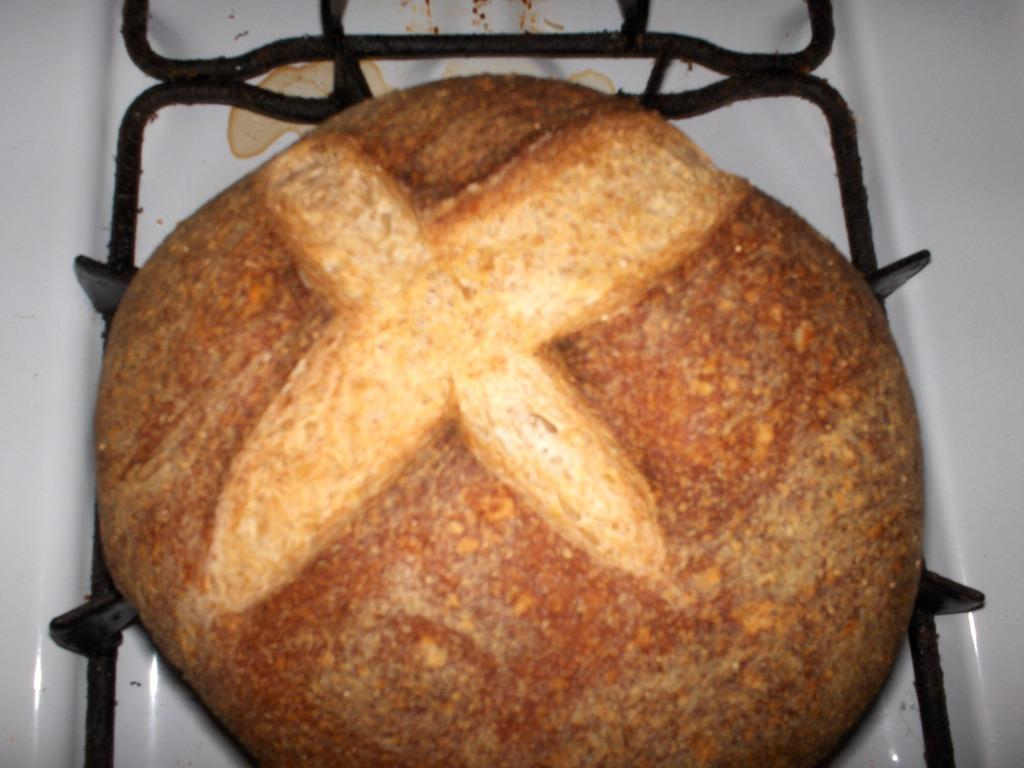What is the main subject of the image? The main subject of the image is food on a stand. Can you describe the food on the stand? Unfortunately, the specific type of food cannot be determined from the given facts. Are there any other objects or elements visible in the image? No additional information about the image is provided in the given facts. How many shoes are visible in the image? There is no mention of shoes in the given facts, so we cannot determine if any are present in the image. 